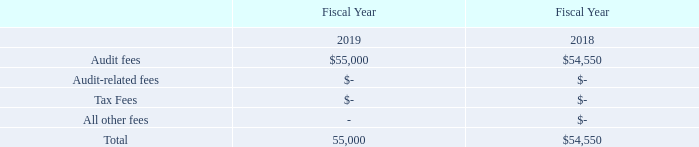Item 14. Principal Accounting Fees and Services
The following table sets forth the fees for services provided and reasonably expected to be billed by Malone Bailey LLP. The following is a summary of the fees billed to the Company for professional services rendered for the fiscal years ended December 31, 2019 and 2018.
Audit Fees: For the fiscal years ended December 31, 2019 and 2018, the aggregate audit fees billed by our independent auditors were for professional services rendered for
audits and quarterly reviews of our consolidated financial statements, and assistance with reviews of registration statements and documents filed with the SEC.
Audit-Related Fees: Audit-related fees are for assurance and other activities not explicitly related to the audit of our financial statements.
Tax Fees: For the fiscal years ended December 31, 2019 and 2018, there were no tax fees, respectively.
All Other Fees: For the fiscal years ended December 31, 2019 and 2018, there were $0 and $0, respectively.
Audit Committee Pre-Approval Policies and Procedures. The Audit Committee oversees and monitors our financial reporting process and internal control system, reviews and
evaluates the audit performed by our registered independent public accountants and reports to the Board any substantive issues found during the audit. The Audit Committee
is directly responsible for the appointment, compensation and oversight of the work of our registered independent public accountants. The Audit Committee convenes on a
quarterly basis to approve each quarterly filing, and an annual basis to review the engagement of the Company’s external auditor.
The Audit Committee has considered whether the provision of Audit-Related Fees, Tax Fees, and all other fees as described above is compatible with maintaining
Marcum LLP’s and Malone Bailey LLP’s independence and has determined that such services for fiscal years 2019 and 2018, respectively, were compatible. All such services
were approved by the Audit Committee pursuant to Rule 2-01 of Regulation S-X under the Exchange Act to the extent that rule was applicable.
What are the tax fees for the fiscal year ended December 2018? There were no tax fees. What are the tax fees for the fiscal year ended December 2019? There were no tax fees. What does audit-related fees refer to? Assurance and other activities not explicitly related to the audit of our financial statements. What is the percentage change in audit fees between 2018 and 2019?
Answer scale should be: percent. (55,000 - 54,550)/54,550 
Answer: 0.82. What is the change in audit fees between 2018 and 2019? 55,000 - 54,550 
Answer: 450. Which year has the higher audit fees? Obtained from the table
Answer: 2019. 